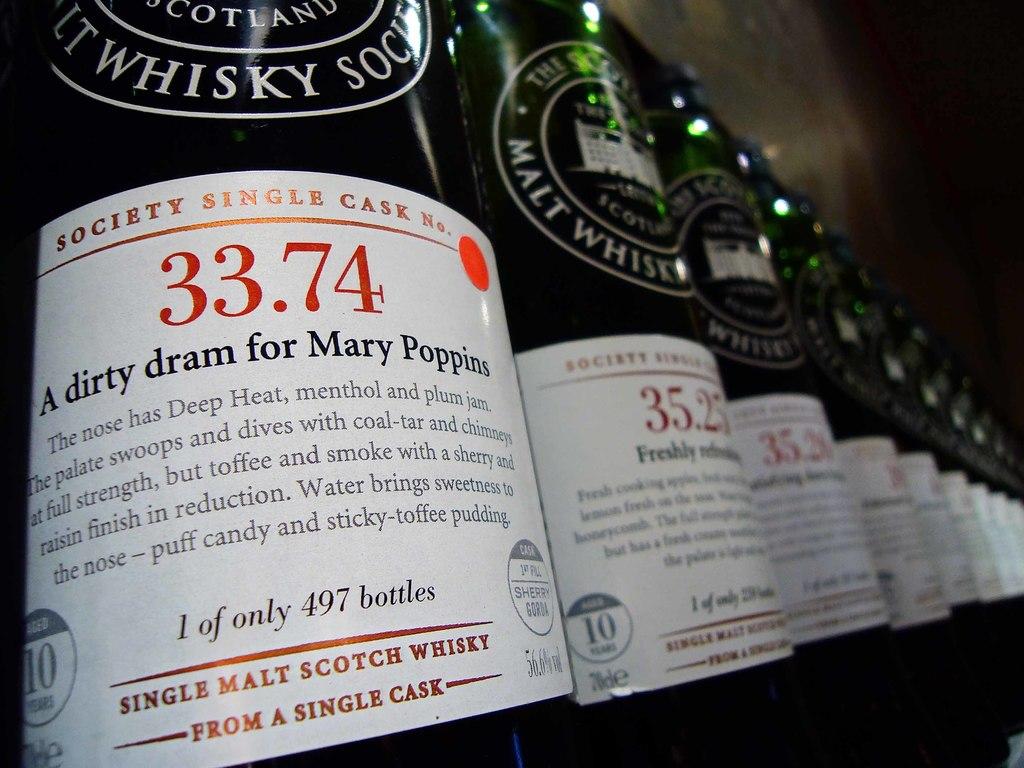What is the number in red?
Give a very brief answer. 33.74. 